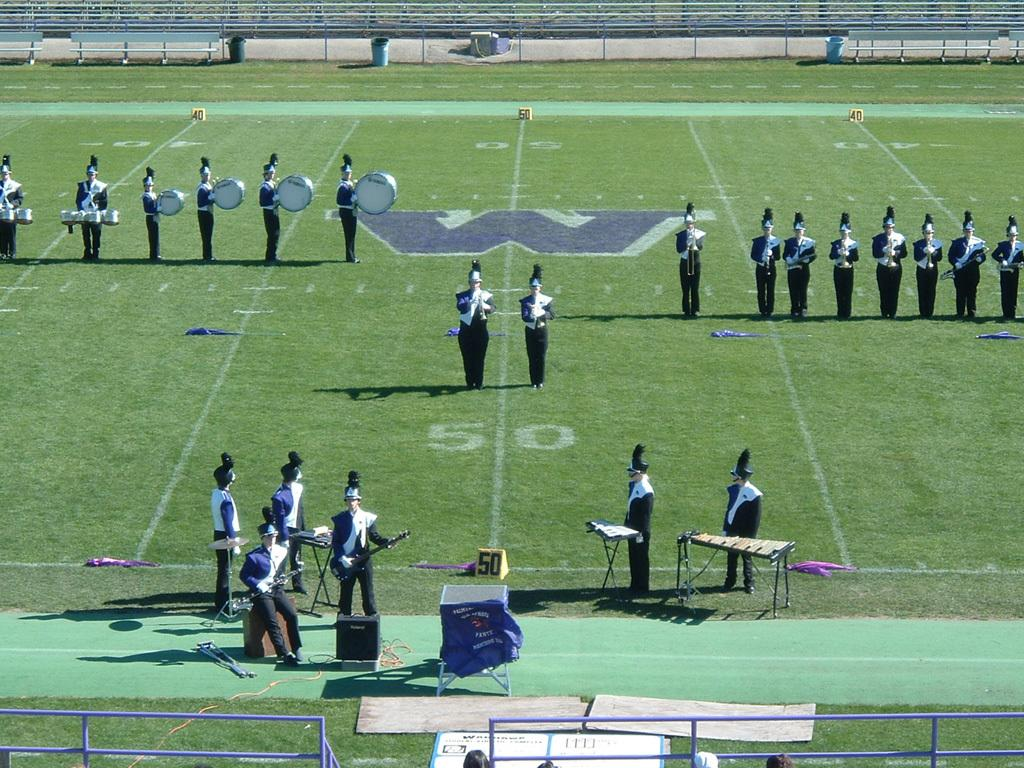Provide a one-sentence caption for the provided image. The band is on a football field with Yamaha bass drums. 